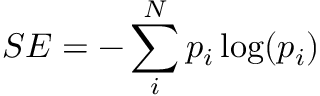Convert formula to latex. <formula><loc_0><loc_0><loc_500><loc_500>S E = - \sum _ { i } ^ { N } p _ { i } \log ( p _ { i } )</formula> 